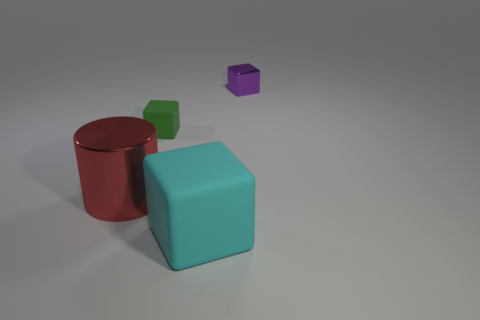Subtract all yellow blocks. Subtract all red balls. How many blocks are left? 3 Add 2 red metal things. How many objects exist? 6 Subtract all cylinders. How many objects are left? 3 Subtract all cyan things. Subtract all small purple blocks. How many objects are left? 2 Add 4 small green blocks. How many small green blocks are left? 5 Add 3 large cylinders. How many large cylinders exist? 4 Subtract 0 yellow cylinders. How many objects are left? 4 